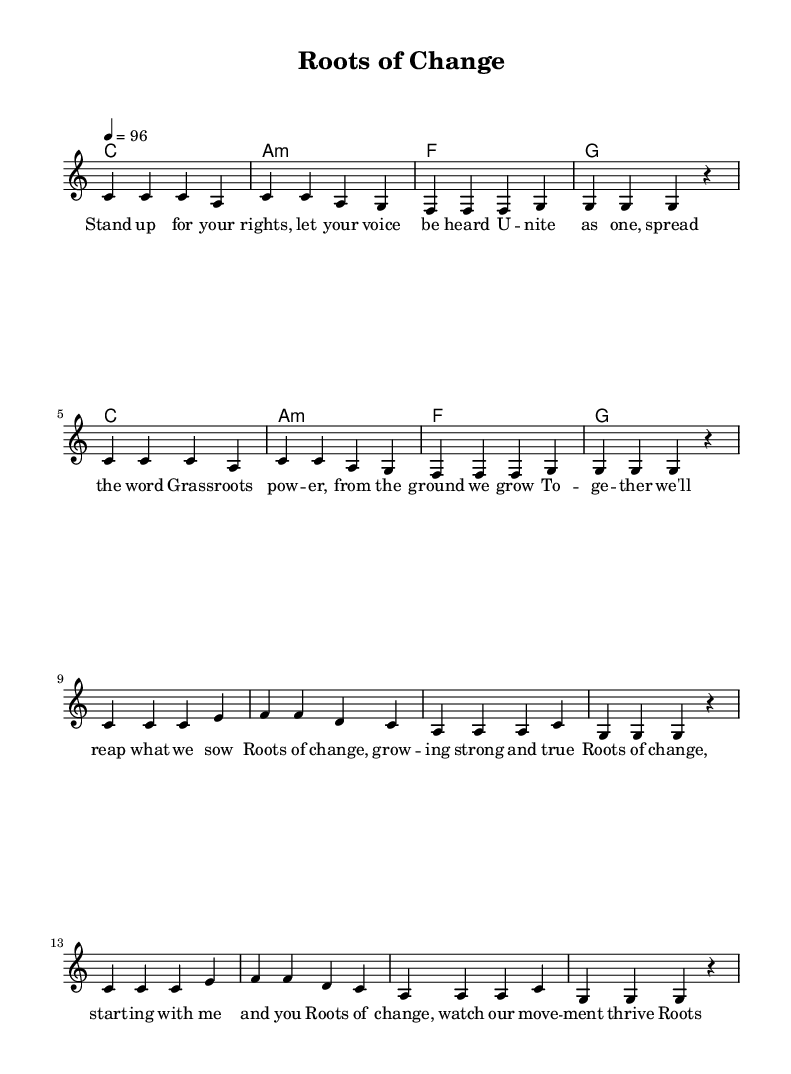What is the key signature of this music? The key signature is indicated at the beginning of the score. In this case, it shows C major, which has no sharps or flats.
Answer: C major What is the time signature of this piece? The time signature is specified at the start of the music, indicating how many beats are in each measure. Here, it is 4/4, meaning there are four beats per measure.
Answer: 4/4 What is the tempo marking for this tune? The tempo is noted as a quarter note equals 96 beats per minute, which sets the pace for the performance of the piece.
Answer: 96 How many measures are in the verse? The verse consists of two sections, each containing four measures, resulting in a total of eight measures overall in the verse.
Answer: 8 What type of chord is used in measure 2? The chord in measure 2 is an A minor chord, indicated in the chord symbols placed above the staff.
Answer: A minor Which musical section contains the lyrics "Roots of change, keeping hope alive”? This line is part of the chorus section of the song, which follows the verse in structure.
Answer: Chorus What is a key theme reflected in the lyrics? The lyrics emphasize community empowerment and grassroots movements, promoting unity and growth from within.
Answer: Community empowerment 